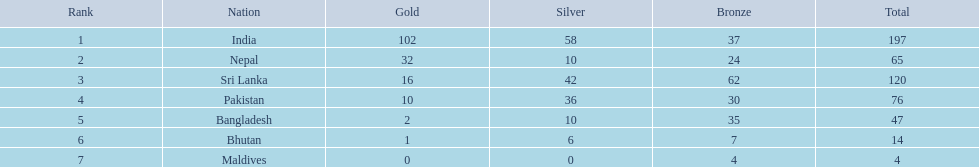Which countries won medals? India, Nepal, Sri Lanka, Pakistan, Bangladesh, Bhutan, Maldives. Which won the most? India. Which won the fewest? Maldives. 